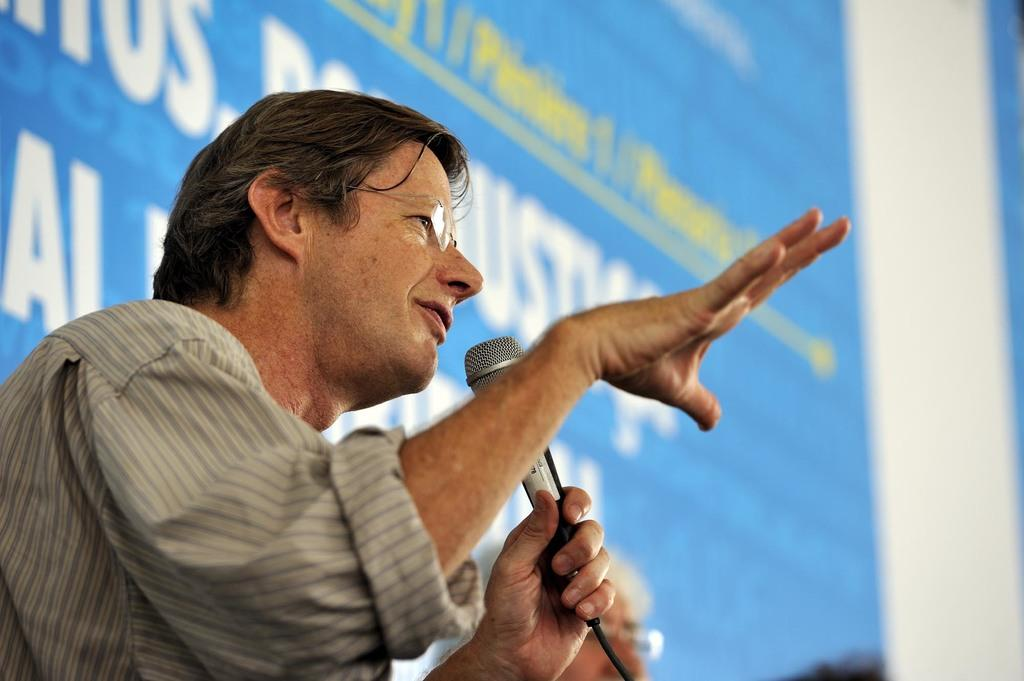What is the man in the image holding? The man is holding a mic in his hand. What can be seen in the background of the image? There is a banner in the background of the image. How many people are visible at the bottom of the image? There are two people at the bottom of the image. What type of tooth can be seen in the image? There is no tooth present in the image. How does the tiger in the image communicate with the audience? There is no tiger present in the image. 